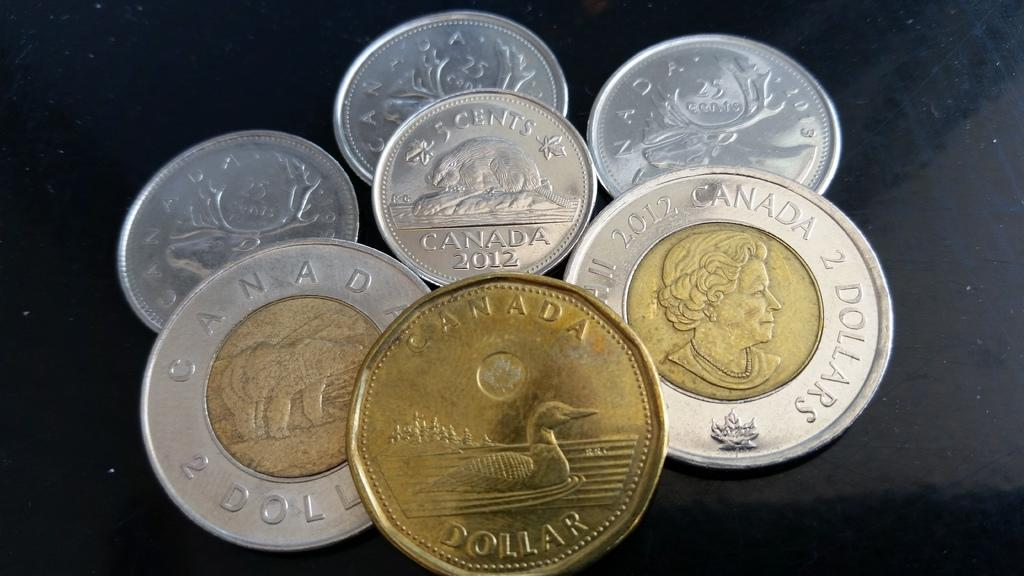<image>
Present a compact description of the photo's key features. A variety of Canadian coins piled on top of each other. 